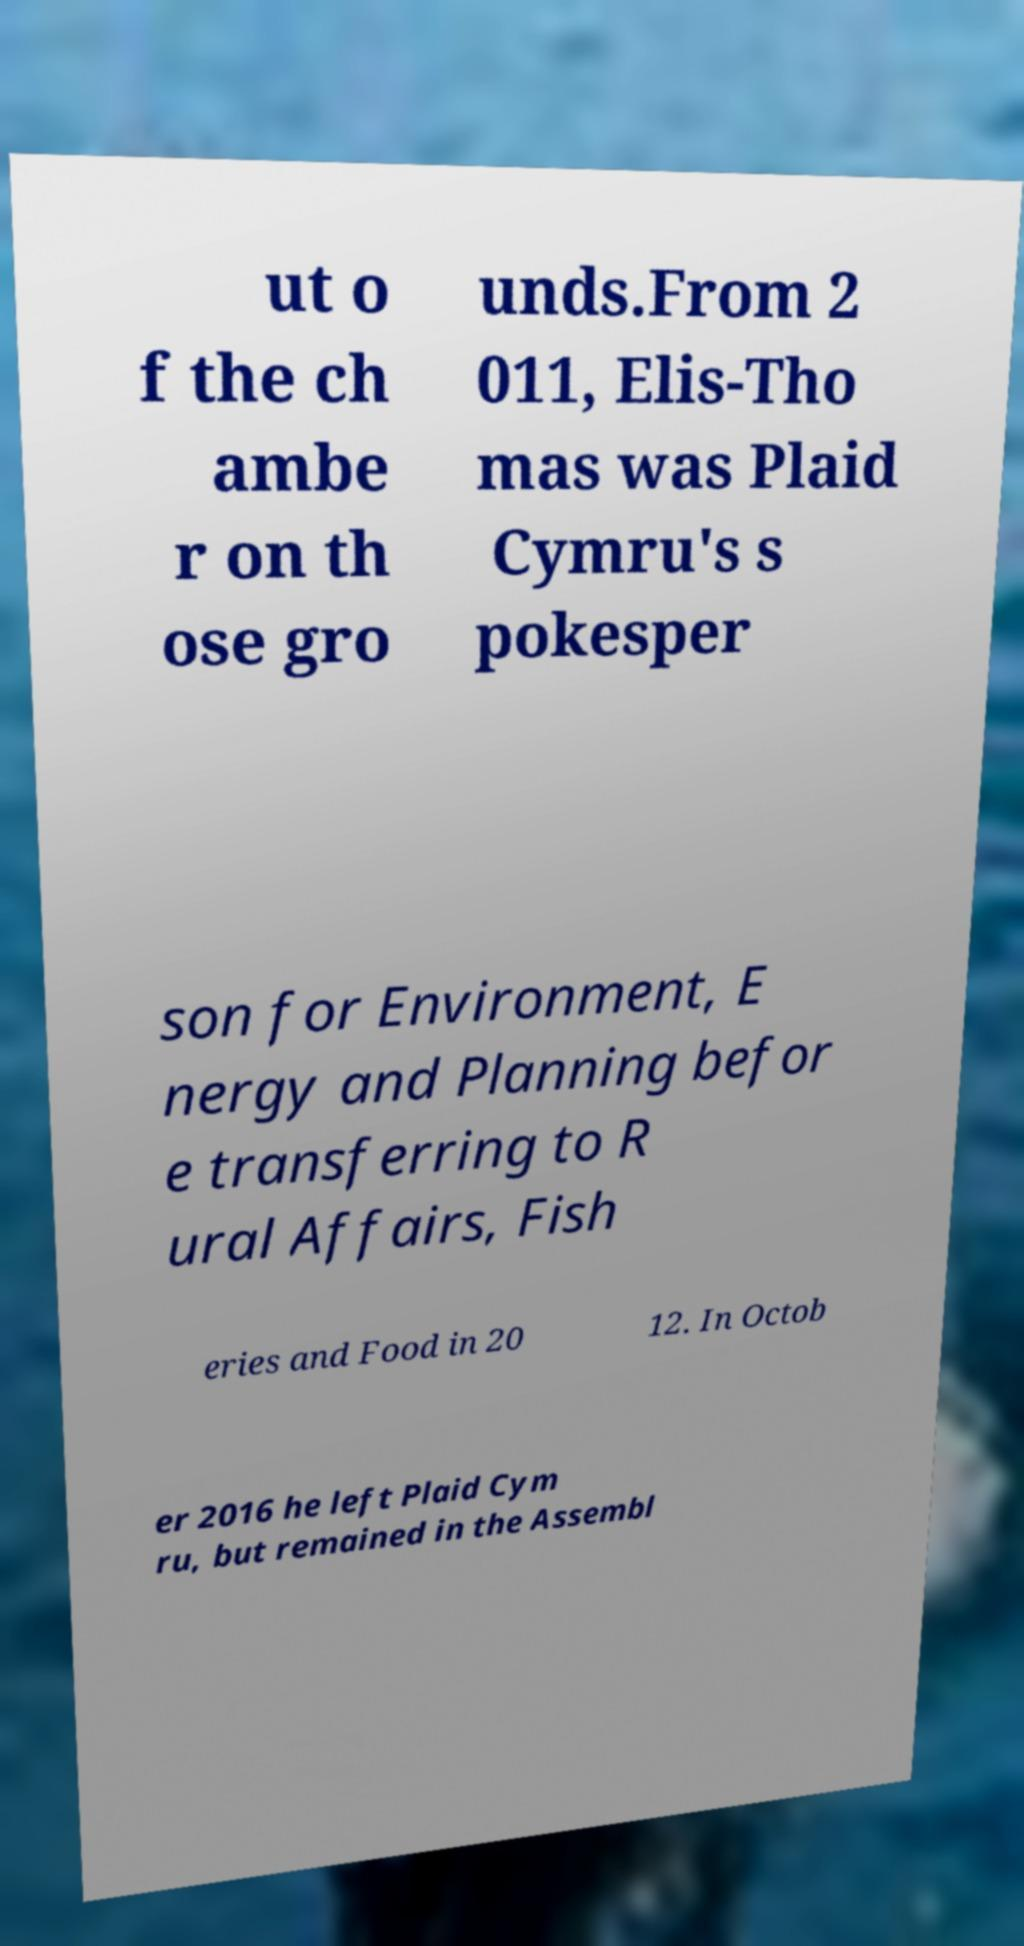For documentation purposes, I need the text within this image transcribed. Could you provide that? ut o f the ch ambe r on th ose gro unds.From 2 011, Elis-Tho mas was Plaid Cymru's s pokesper son for Environment, E nergy and Planning befor e transferring to R ural Affairs, Fish eries and Food in 20 12. In Octob er 2016 he left Plaid Cym ru, but remained in the Assembl 